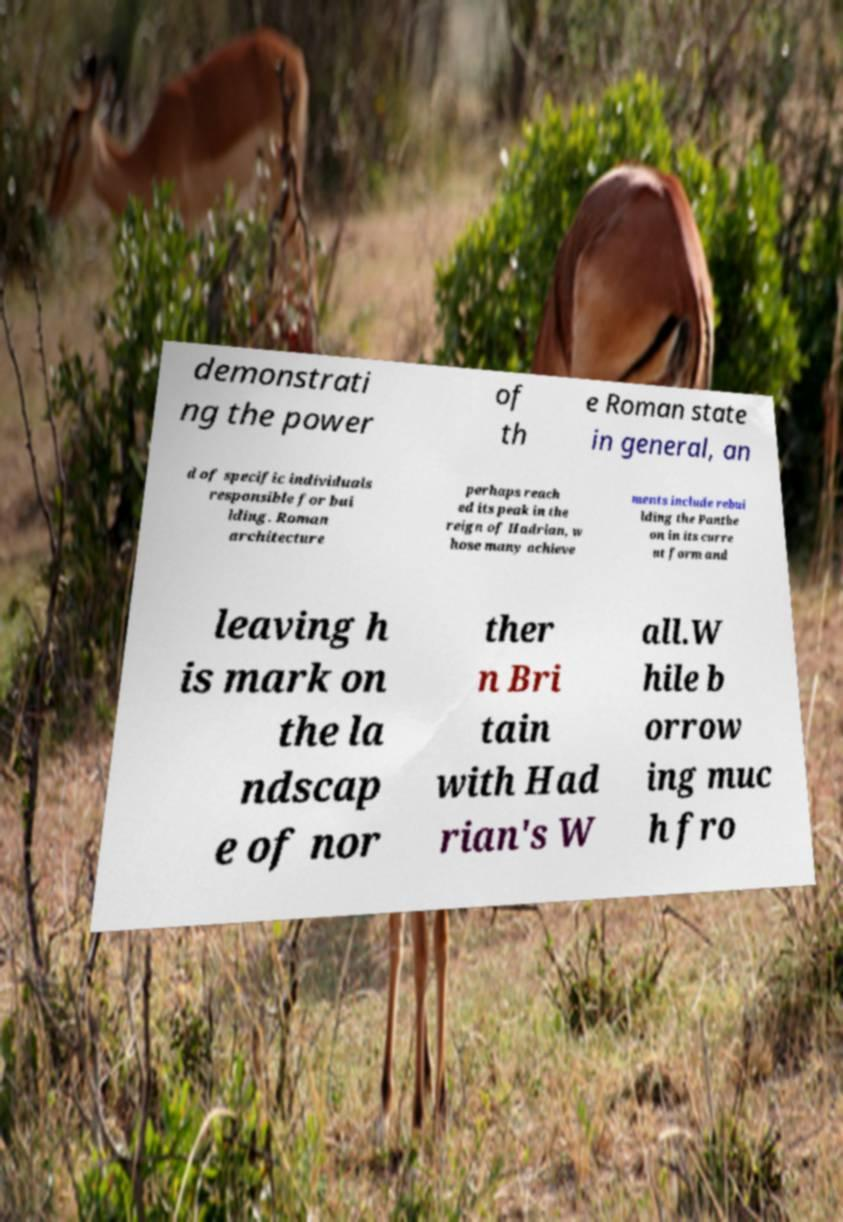Can you read and provide the text displayed in the image?This photo seems to have some interesting text. Can you extract and type it out for me? demonstrati ng the power of th e Roman state in general, an d of specific individuals responsible for bui lding. Roman architecture perhaps reach ed its peak in the reign of Hadrian, w hose many achieve ments include rebui lding the Panthe on in its curre nt form and leaving h is mark on the la ndscap e of nor ther n Bri tain with Had rian's W all.W hile b orrow ing muc h fro 